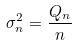<formula> <loc_0><loc_0><loc_500><loc_500>\sigma _ { n } ^ { 2 } = \frac { Q _ { n } } { n }</formula> 